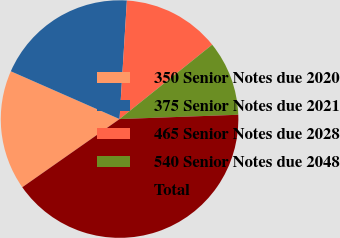Convert chart to OTSL. <chart><loc_0><loc_0><loc_500><loc_500><pie_chart><fcel>350 Senior Notes due 2020<fcel>375 Senior Notes due 2021<fcel>465 Senior Notes due 2028<fcel>540 Senior Notes due 2048<fcel>Total<nl><fcel>16.32%<fcel>19.39%<fcel>13.25%<fcel>10.19%<fcel>40.85%<nl></chart> 